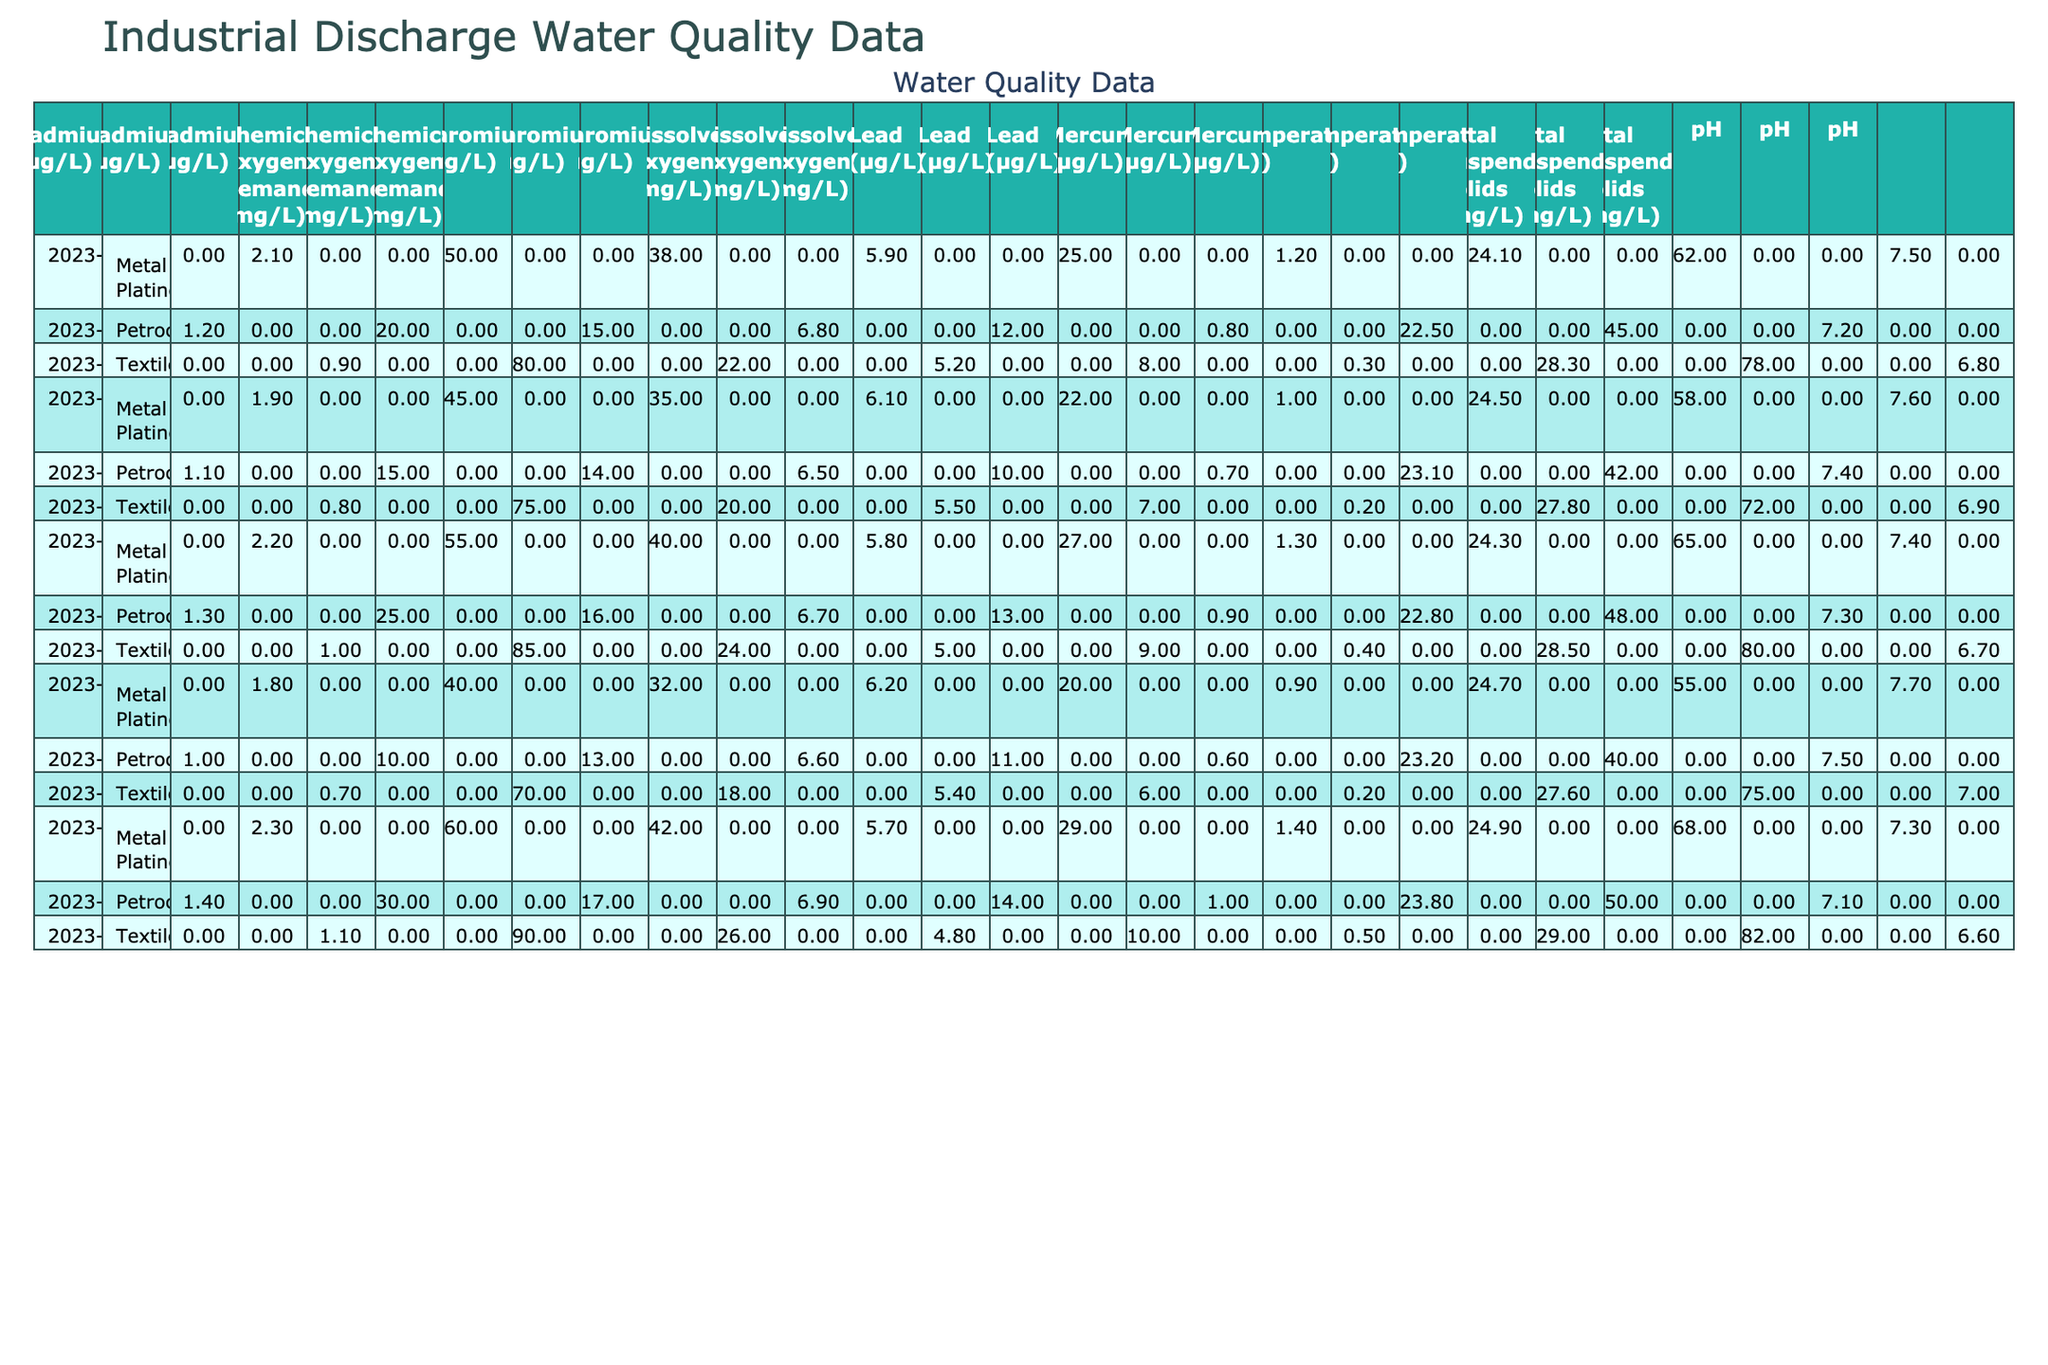What is the pH level at the MetalWorks Inc. Pipe on March 25, 2023? The pH level is found under the 'pH' column for the 'MetalWorks Inc. Pipe' row on March 25, 2023. The value listed is 7.4.
Answer: 7.4 What was the average temperature recorded at the Riverside Textiles Drain from January to May 2023? To find the average, sum the temperatures recorded from January to May for Riverside Textiles Drain: (28.3 + 27.8 + 28.5 + 27.6 + 29.0) = 141.2. Then divide the total by the number of months (5): 141.2 / 5 = 28.24.
Answer: 28.24 Is the dissolved oxygen level at Acme Chemical Outfall consistently above 6 mg/L? Checking the dissolved oxygen levels for Acme Chemical Outfall across January (6.8), February (6.5), March (6.7), April (6.6), and May (6.9), all values are indeed above 6 mg/L.
Answer: Yes What is the maximum concentration of lead measured at the MetalWorks Inc. Pipe over the provided dates? The lead concentrations for MetalWorks Inc. Pipe are: 25 µg/L (Jan), 22 µg/L (Feb), 27 µg/L (Mar), 20 µg/L (Apr), and 29 µg/L (May). The maximum value is 29 µg/L in May.
Answer: 29 µg/L On average, how much total suspended solids were measured at Acme Chemical Outfall across all the provided dates? Total suspended solids measurements for Acme are: 45 (Jan), 42 (Feb), 48 (Mar), 40 (Apr), and 50 (May). Summing these gives (45 + 42 + 48 + 40 + 50) = 225. To find the average, divide by total observations (5): 225 / 5 = 45.
Answer: 45 Which discharge point recorded the highest chemical oxygen demand on February 20, 2023? Examining the chemical oxygen demand on February 20, 2023, we find: Acme Chemical (115 mg/L), Riverside Textiles (175 mg/L), and MetalWorks Inc. (145 mg/L). The highest is 175 mg/L at Riverside Textiles.
Answer: 175 mg/L Was there any mercury detected at the Riverside Textiles Drain during any of the measured dates? Review the mercury levels for Riverside Textiles Drain: January (0.3), February (0.2), March (0.4), April (0.2), May (0.5). Since all values are non-zero, mercury was detected in every instance.
Answer: Yes What is the difference in total suspended solids between Acme Chemical Outfall and MetalWorks Inc. Pipe for May 2023? For May 2023, Acme has 50 mg/L and MetalWorks has 68 mg/L. The difference is calculated as: 68 - 50 = 18 mg/L.
Answer: 18 mg/L What trend, if any, can be observed regarding the lead concentration at the Acme Chemical Outfall from January to May 2023? The lead concentrations for Acme Chemical Outfall are: 12 (Jan), 10 (Feb), 13 (Mar), 11 (Apr), and 14 (May). Analyzing these numbers, the lead concentration shows a slight increasing trend over time.
Answer: Increasing trend 